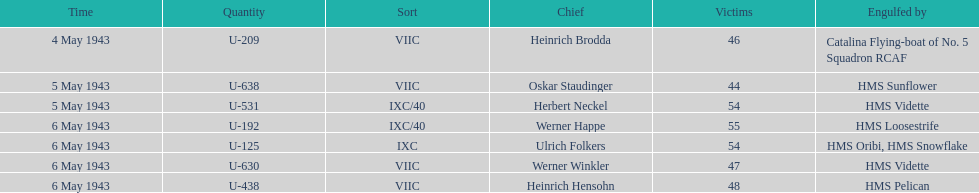Which u-boat had more than 54 casualties? U-192. 